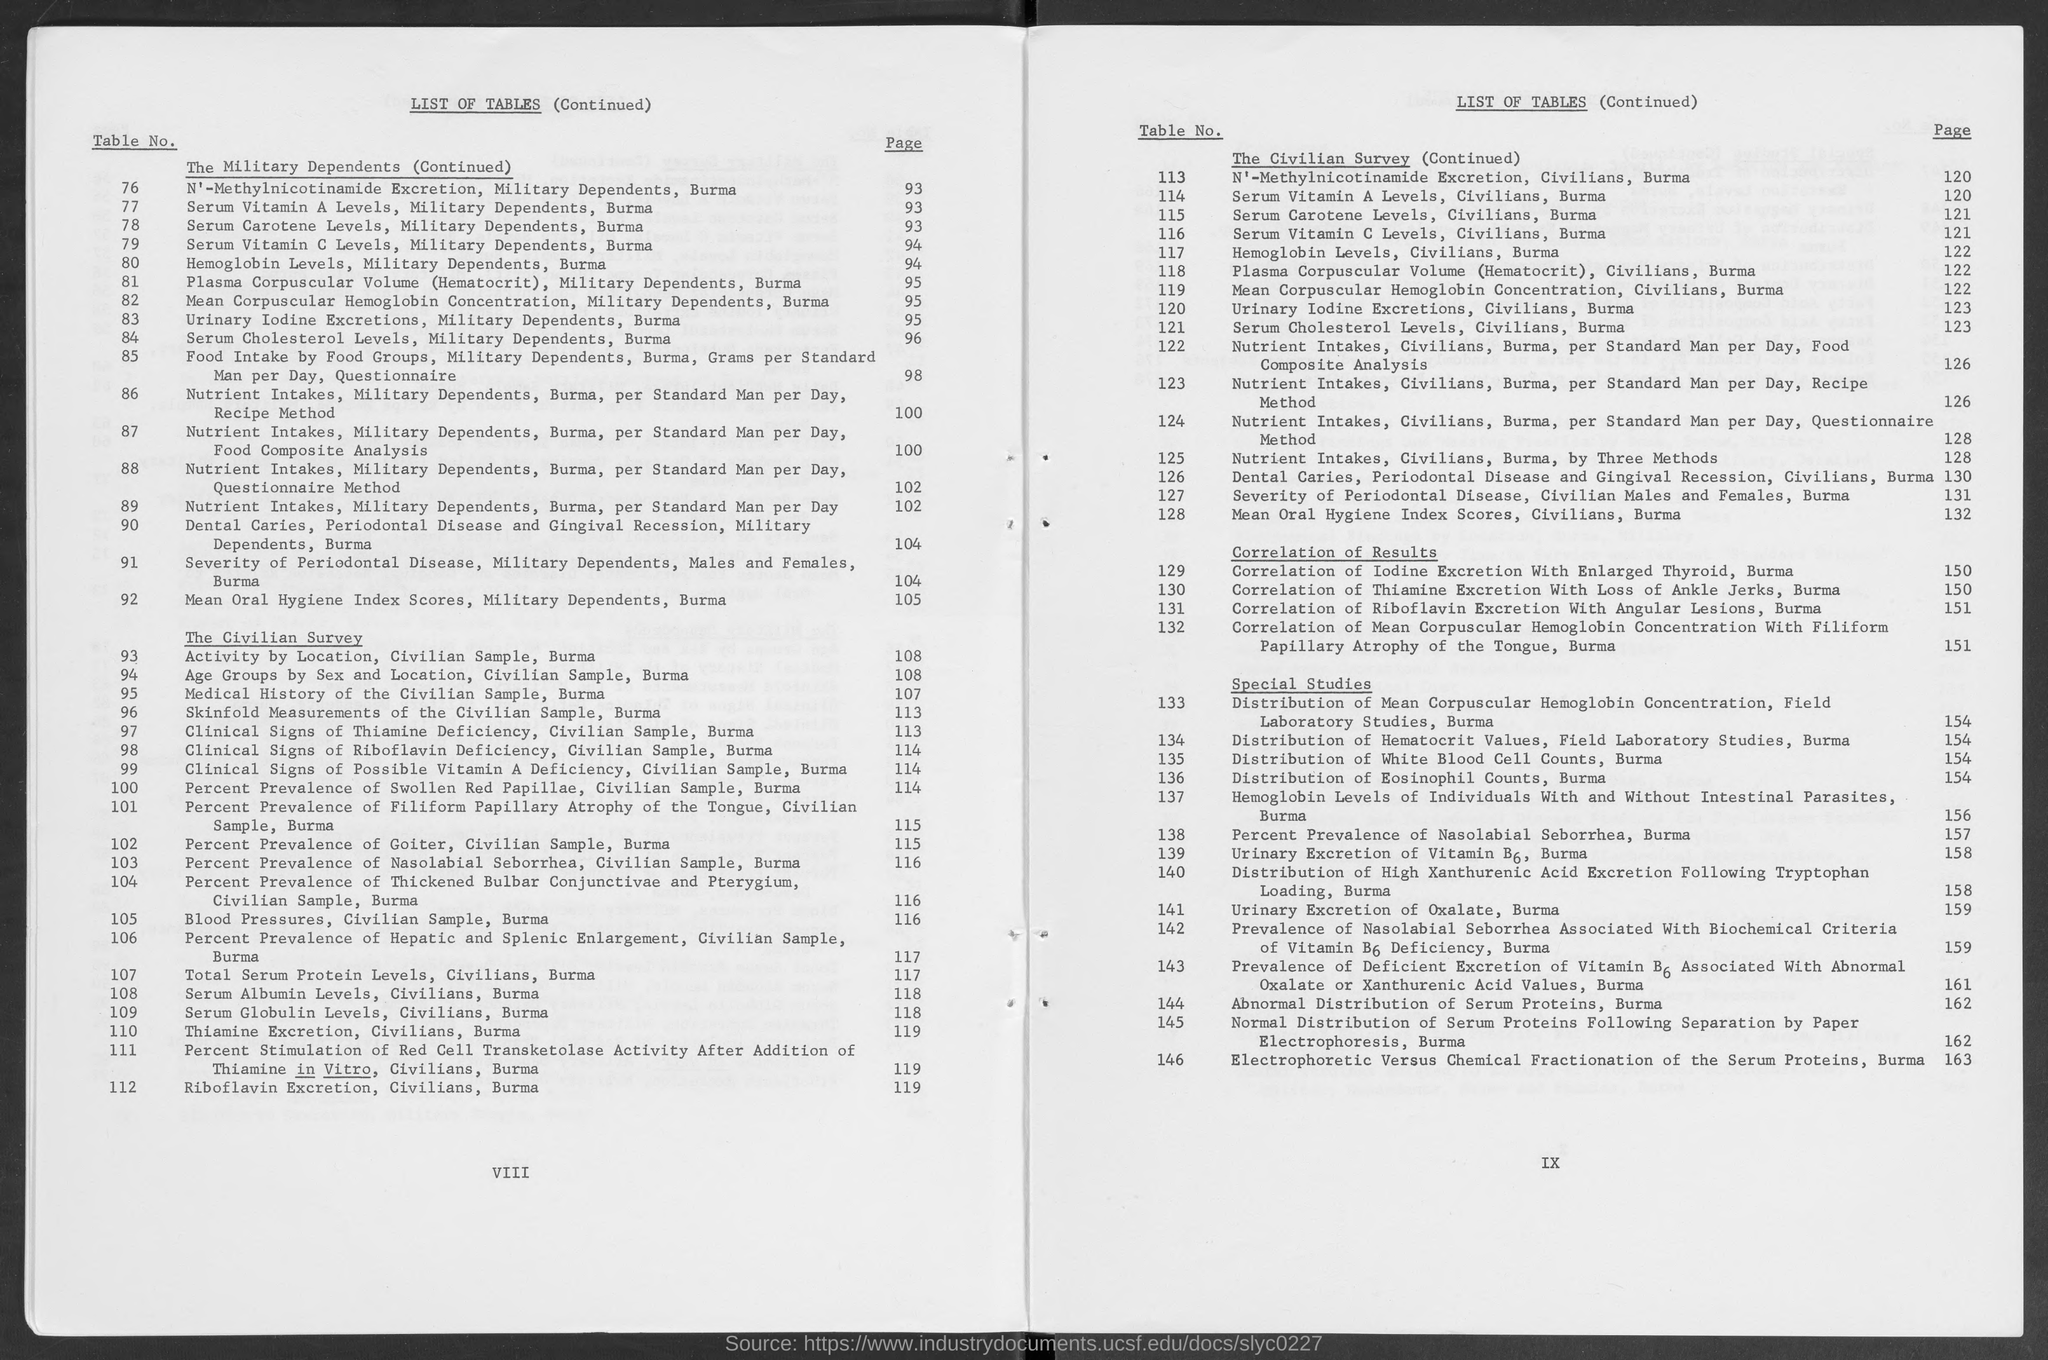Point out several critical features in this image. The page number for Table no. 117 is 122. Table no. 122 can be found on page 126. The page number for Table no. 113 is 120. Please provide the page number for Table no. 121, which is located between pages 123 and 124. The question asks for the page number of Table No. 120. The answer is provided as "123... 